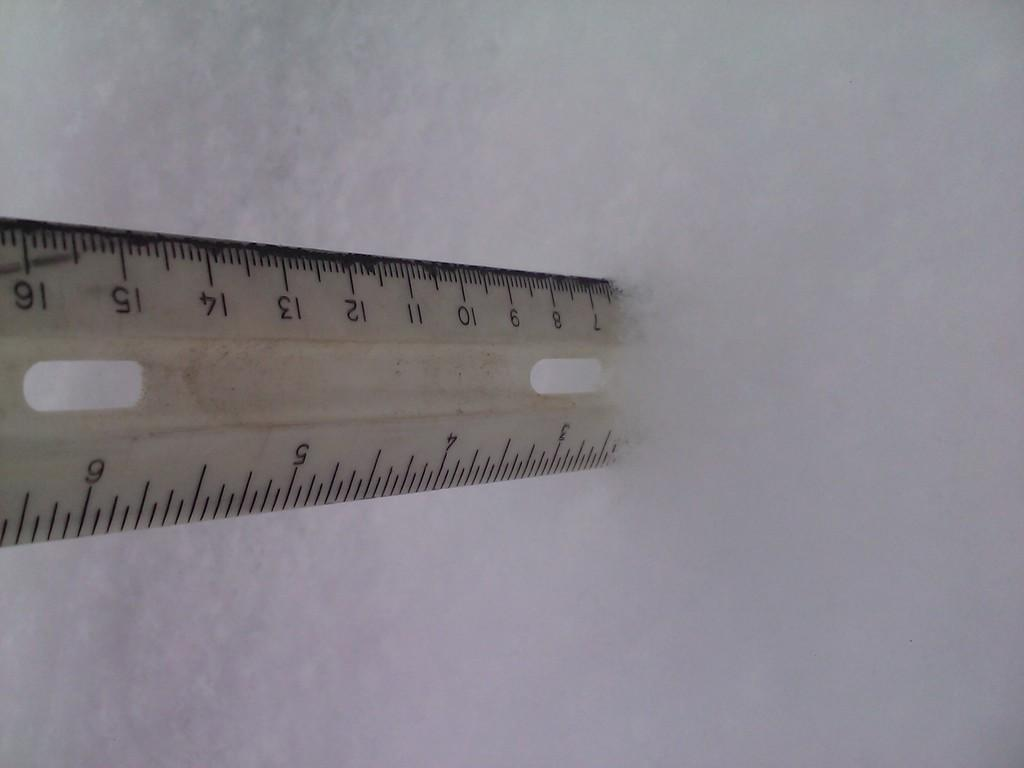Provide a one-sentence caption for the provided image. A rules is sticking out of the snow, showing the depth at about 2 and a half inches. 